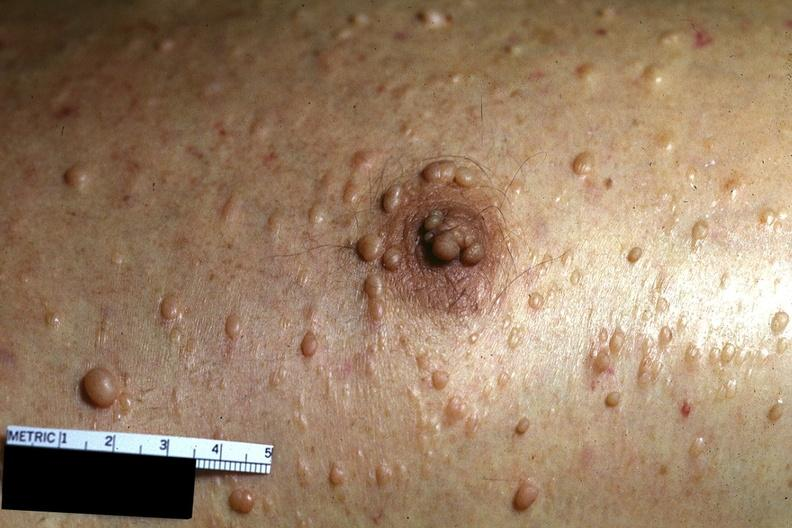does this image show skin, neurofibromatosis?
Answer the question using a single word or phrase. Yes 